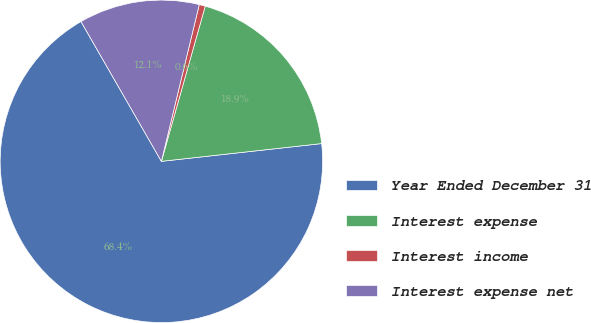<chart> <loc_0><loc_0><loc_500><loc_500><pie_chart><fcel>Year Ended December 31<fcel>Interest expense<fcel>Interest income<fcel>Interest expense net<nl><fcel>68.45%<fcel>18.86%<fcel>0.61%<fcel>12.08%<nl></chart> 